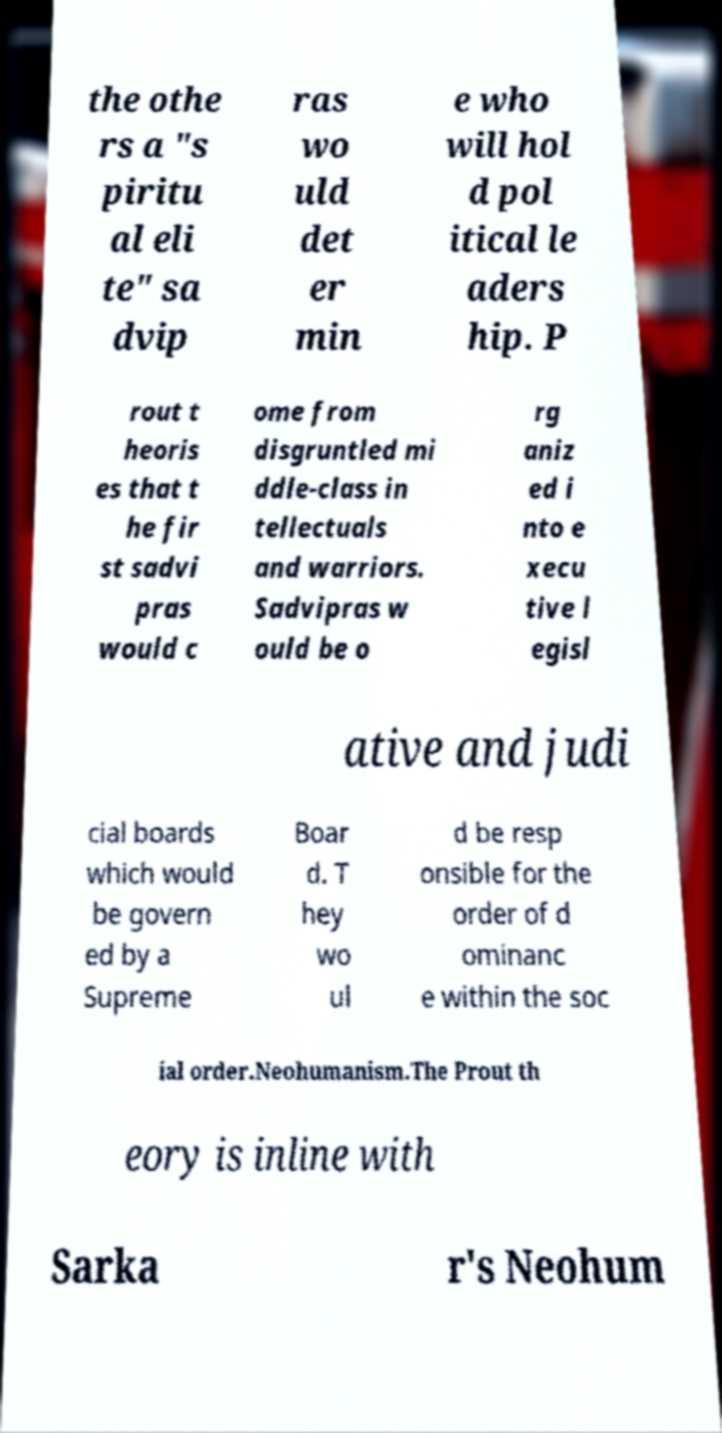I need the written content from this picture converted into text. Can you do that? the othe rs a "s piritu al eli te" sa dvip ras wo uld det er min e who will hol d pol itical le aders hip. P rout t heoris es that t he fir st sadvi pras would c ome from disgruntled mi ddle-class in tellectuals and warriors. Sadvipras w ould be o rg aniz ed i nto e xecu tive l egisl ative and judi cial boards which would be govern ed by a Supreme Boar d. T hey wo ul d be resp onsible for the order of d ominanc e within the soc ial order.Neohumanism.The Prout th eory is inline with Sarka r's Neohum 